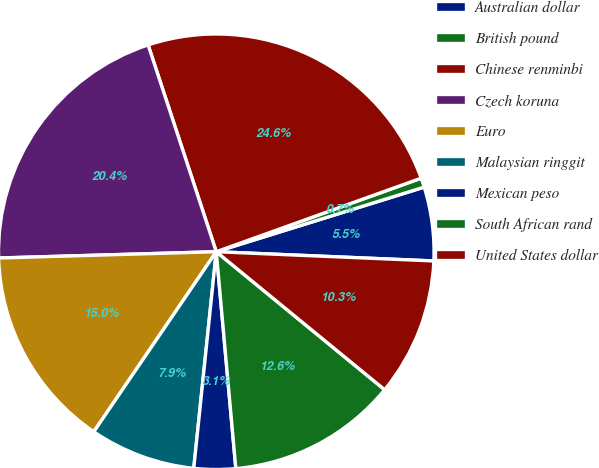Convert chart to OTSL. <chart><loc_0><loc_0><loc_500><loc_500><pie_chart><fcel>Australian dollar<fcel>British pound<fcel>Chinese renminbi<fcel>Czech koruna<fcel>Euro<fcel>Malaysian ringgit<fcel>Mexican peso<fcel>South African rand<fcel>United States dollar<nl><fcel>5.47%<fcel>0.69%<fcel>24.58%<fcel>20.39%<fcel>15.03%<fcel>7.86%<fcel>3.08%<fcel>12.64%<fcel>10.25%<nl></chart> 